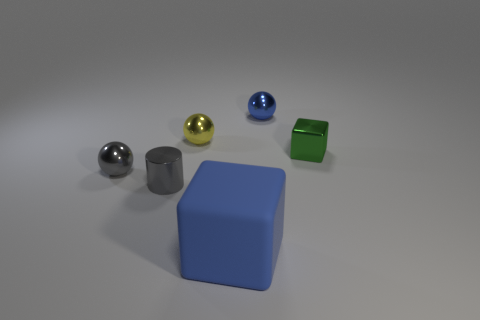Subtract all tiny yellow spheres. How many spheres are left? 2 Subtract all cyan spheres. Subtract all brown cubes. How many spheres are left? 3 Subtract all cylinders. How many objects are left? 5 Add 4 tiny metal cubes. How many objects exist? 10 Subtract 0 yellow cylinders. How many objects are left? 6 Subtract all small gray metal things. Subtract all yellow shiny objects. How many objects are left? 3 Add 6 gray things. How many gray things are left? 8 Add 2 large green shiny balls. How many large green shiny balls exist? 2 